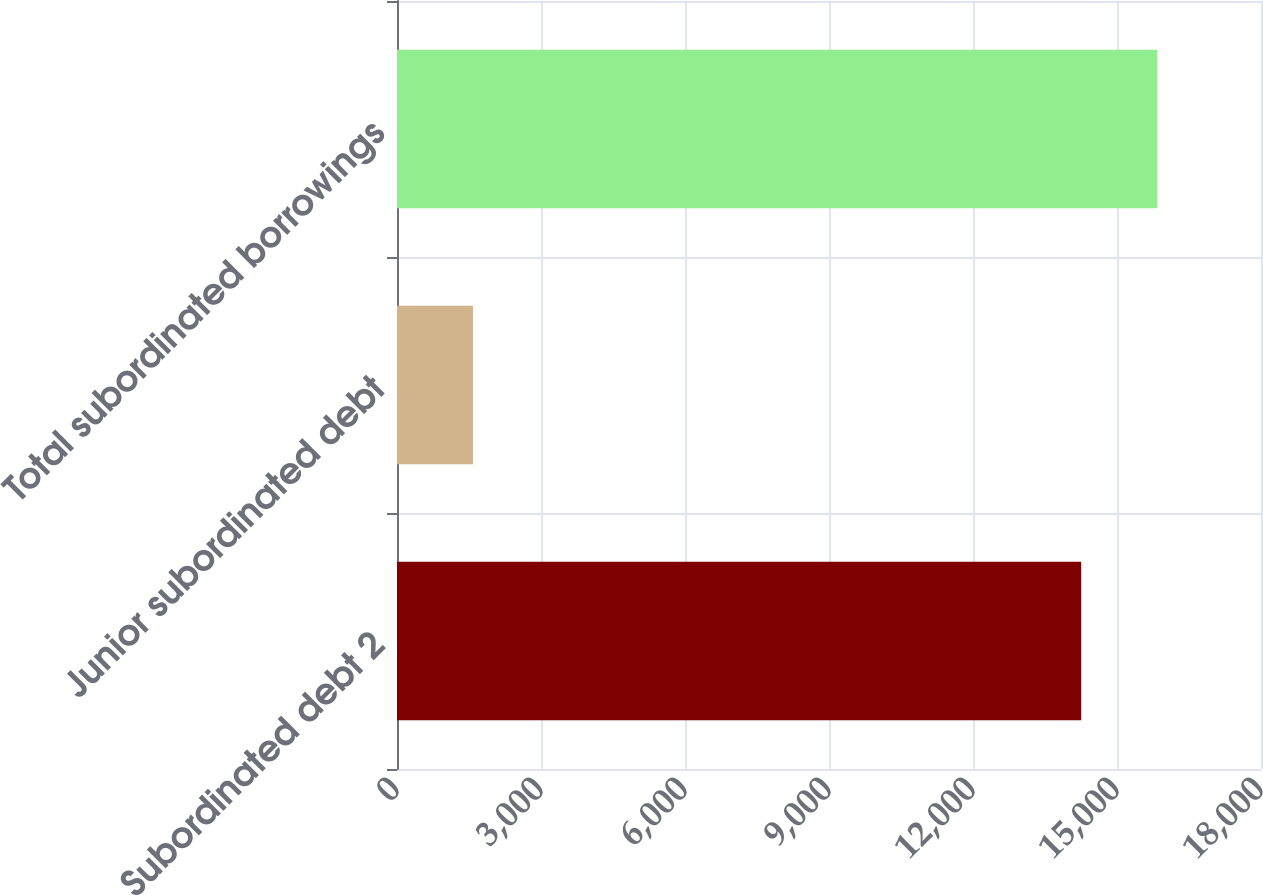Convert chart. <chart><loc_0><loc_0><loc_500><loc_500><bar_chart><fcel>Subordinated debt 2<fcel>Junior subordinated debt<fcel>Total subordinated borrowings<nl><fcel>14254<fcel>1582<fcel>15836<nl></chart> 